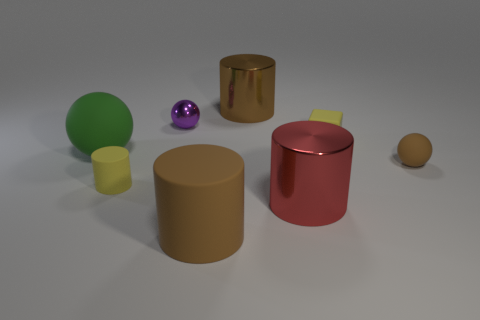If these objects were real, which one would weigh the most? If these objects were real, the large red cylinder would likely weigh the most due to its size and appearance of being made of metal, which typically has a higher density than materials like plastic or rubber. 